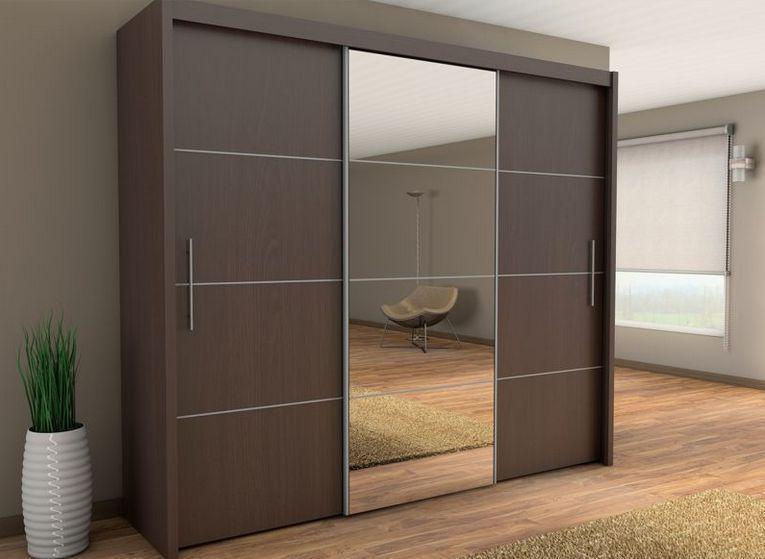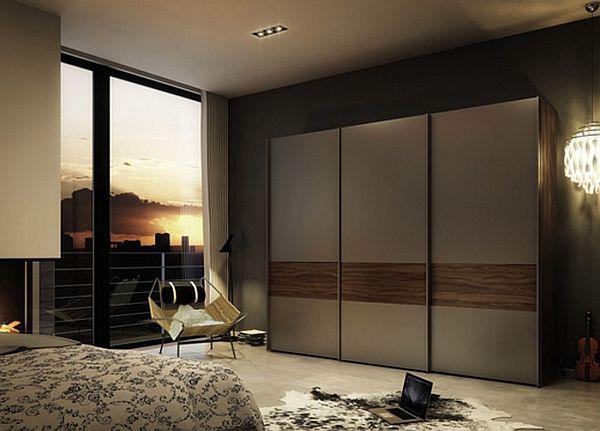The first image is the image on the left, the second image is the image on the right. For the images displayed, is the sentence "An image shows a wardrobe with mirror on the right and black panel on the left." factually correct? Answer yes or no. No. 